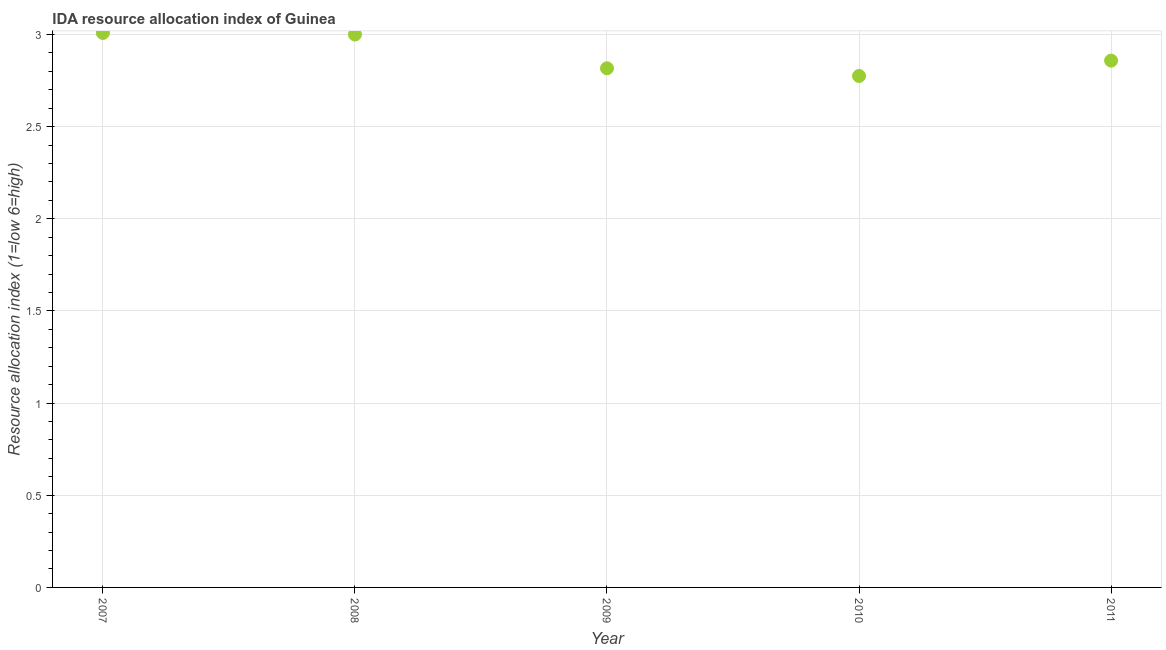What is the ida resource allocation index in 2009?
Offer a very short reply. 2.82. Across all years, what is the maximum ida resource allocation index?
Your response must be concise. 3.01. Across all years, what is the minimum ida resource allocation index?
Offer a terse response. 2.77. In which year was the ida resource allocation index maximum?
Keep it short and to the point. 2007. What is the sum of the ida resource allocation index?
Your response must be concise. 14.46. What is the difference between the ida resource allocation index in 2008 and 2010?
Your response must be concise. 0.23. What is the average ida resource allocation index per year?
Ensure brevity in your answer.  2.89. What is the median ida resource allocation index?
Offer a terse response. 2.86. What is the ratio of the ida resource allocation index in 2010 to that in 2011?
Provide a succinct answer. 0.97. Is the difference between the ida resource allocation index in 2009 and 2010 greater than the difference between any two years?
Make the answer very short. No. What is the difference between the highest and the second highest ida resource allocation index?
Your answer should be compact. 0.01. What is the difference between the highest and the lowest ida resource allocation index?
Your answer should be compact. 0.23. What is the difference between two consecutive major ticks on the Y-axis?
Your response must be concise. 0.5. What is the title of the graph?
Offer a very short reply. IDA resource allocation index of Guinea. What is the label or title of the Y-axis?
Provide a succinct answer. Resource allocation index (1=low 6=high). What is the Resource allocation index (1=low 6=high) in 2007?
Provide a short and direct response. 3.01. What is the Resource allocation index (1=low 6=high) in 2009?
Give a very brief answer. 2.82. What is the Resource allocation index (1=low 6=high) in 2010?
Give a very brief answer. 2.77. What is the Resource allocation index (1=low 6=high) in 2011?
Your response must be concise. 2.86. What is the difference between the Resource allocation index (1=low 6=high) in 2007 and 2008?
Give a very brief answer. 0.01. What is the difference between the Resource allocation index (1=low 6=high) in 2007 and 2009?
Your answer should be compact. 0.19. What is the difference between the Resource allocation index (1=low 6=high) in 2007 and 2010?
Offer a terse response. 0.23. What is the difference between the Resource allocation index (1=low 6=high) in 2007 and 2011?
Give a very brief answer. 0.15. What is the difference between the Resource allocation index (1=low 6=high) in 2008 and 2009?
Make the answer very short. 0.18. What is the difference between the Resource allocation index (1=low 6=high) in 2008 and 2010?
Offer a very short reply. 0.23. What is the difference between the Resource allocation index (1=low 6=high) in 2008 and 2011?
Ensure brevity in your answer.  0.14. What is the difference between the Resource allocation index (1=low 6=high) in 2009 and 2010?
Provide a succinct answer. 0.04. What is the difference between the Resource allocation index (1=low 6=high) in 2009 and 2011?
Your response must be concise. -0.04. What is the difference between the Resource allocation index (1=low 6=high) in 2010 and 2011?
Offer a terse response. -0.08. What is the ratio of the Resource allocation index (1=low 6=high) in 2007 to that in 2009?
Your answer should be compact. 1.07. What is the ratio of the Resource allocation index (1=low 6=high) in 2007 to that in 2010?
Your answer should be compact. 1.08. What is the ratio of the Resource allocation index (1=low 6=high) in 2007 to that in 2011?
Provide a succinct answer. 1.05. What is the ratio of the Resource allocation index (1=low 6=high) in 2008 to that in 2009?
Your answer should be very brief. 1.06. What is the ratio of the Resource allocation index (1=low 6=high) in 2008 to that in 2010?
Your answer should be compact. 1.08. What is the ratio of the Resource allocation index (1=low 6=high) in 2009 to that in 2010?
Make the answer very short. 1.01. What is the ratio of the Resource allocation index (1=low 6=high) in 2010 to that in 2011?
Give a very brief answer. 0.97. 